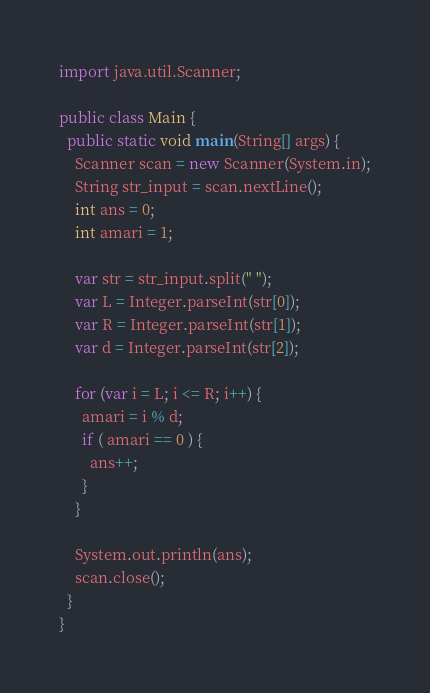<code> <loc_0><loc_0><loc_500><loc_500><_Java_>import java.util.Scanner;

public class Main {
  public static void main(String[] args) {
    Scanner scan = new Scanner(System.in);
    String str_input = scan.nextLine();
    int ans = 0;
    int amari = 1;

    var str = str_input.split(" ");
    var L = Integer.parseInt(str[0]);
    var R = Integer.parseInt(str[1]);
    var d = Integer.parseInt(str[2]);

    for (var i = L; i <= R; i++) {
      amari = i % d;
      if ( amari == 0 ) {
        ans++;
      }
    }

    System.out.println(ans);
    scan.close();
  }
}</code> 